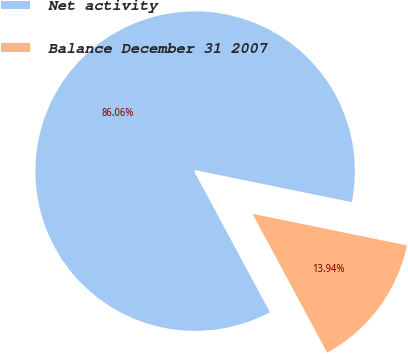Convert chart to OTSL. <chart><loc_0><loc_0><loc_500><loc_500><pie_chart><fcel>Net activity<fcel>Balance December 31 2007<nl><fcel>86.06%<fcel>13.94%<nl></chart> 